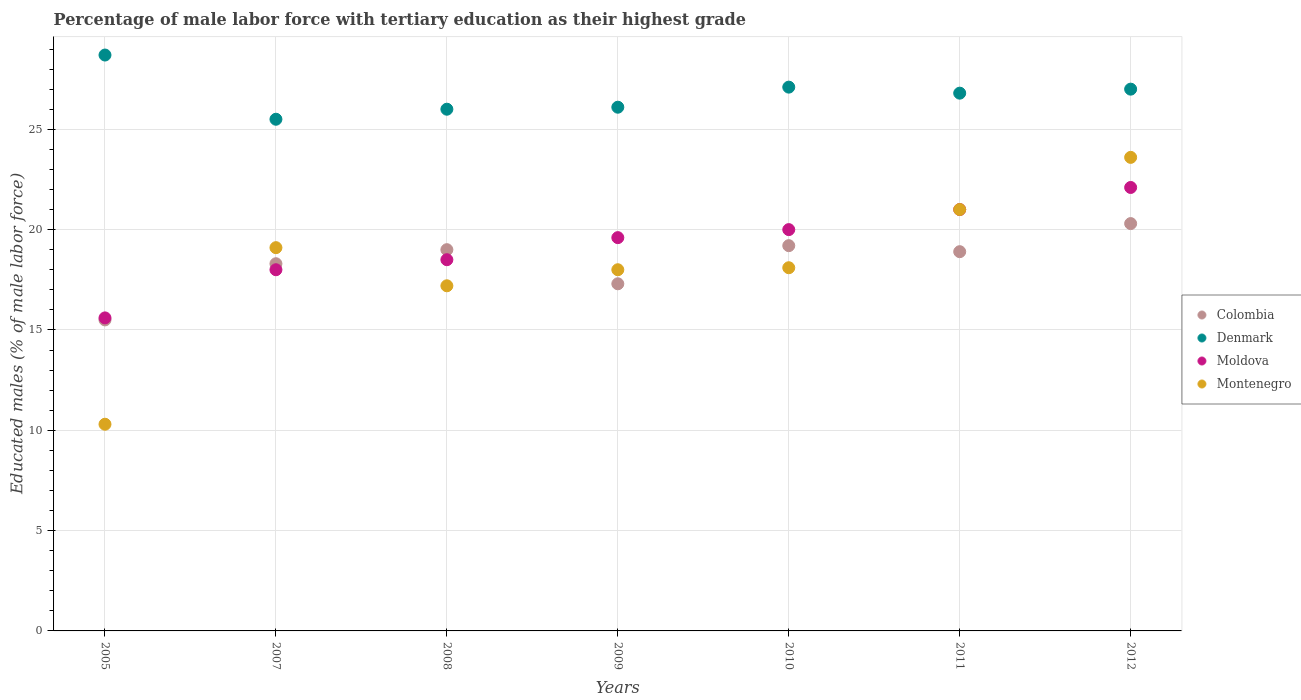What is the percentage of male labor force with tertiary education in Moldova in 2009?
Give a very brief answer. 19.6. Across all years, what is the maximum percentage of male labor force with tertiary education in Moldova?
Provide a succinct answer. 22.1. Across all years, what is the minimum percentage of male labor force with tertiary education in Colombia?
Provide a succinct answer. 15.5. In which year was the percentage of male labor force with tertiary education in Denmark maximum?
Ensure brevity in your answer.  2005. In which year was the percentage of male labor force with tertiary education in Denmark minimum?
Your answer should be very brief. 2007. What is the total percentage of male labor force with tertiary education in Colombia in the graph?
Give a very brief answer. 128.5. What is the difference between the percentage of male labor force with tertiary education in Denmark in 2009 and that in 2012?
Your answer should be very brief. -0.9. What is the difference between the percentage of male labor force with tertiary education in Moldova in 2011 and the percentage of male labor force with tertiary education in Montenegro in 2012?
Offer a very short reply. -2.6. What is the average percentage of male labor force with tertiary education in Colombia per year?
Make the answer very short. 18.36. In the year 2011, what is the difference between the percentage of male labor force with tertiary education in Denmark and percentage of male labor force with tertiary education in Colombia?
Provide a succinct answer. 7.9. What is the ratio of the percentage of male labor force with tertiary education in Moldova in 2010 to that in 2012?
Your answer should be compact. 0.9. Is the difference between the percentage of male labor force with tertiary education in Denmark in 2008 and 2012 greater than the difference between the percentage of male labor force with tertiary education in Colombia in 2008 and 2012?
Provide a short and direct response. Yes. What is the difference between the highest and the second highest percentage of male labor force with tertiary education in Colombia?
Your response must be concise. 1.1. What is the difference between the highest and the lowest percentage of male labor force with tertiary education in Montenegro?
Your response must be concise. 13.3. Is it the case that in every year, the sum of the percentage of male labor force with tertiary education in Denmark and percentage of male labor force with tertiary education in Moldova  is greater than the sum of percentage of male labor force with tertiary education in Montenegro and percentage of male labor force with tertiary education in Colombia?
Offer a terse response. Yes. What is the difference between two consecutive major ticks on the Y-axis?
Offer a terse response. 5. Are the values on the major ticks of Y-axis written in scientific E-notation?
Keep it short and to the point. No. Does the graph contain any zero values?
Your response must be concise. No. Does the graph contain grids?
Provide a short and direct response. Yes. How are the legend labels stacked?
Your answer should be compact. Vertical. What is the title of the graph?
Provide a succinct answer. Percentage of male labor force with tertiary education as their highest grade. Does "San Marino" appear as one of the legend labels in the graph?
Your response must be concise. No. What is the label or title of the X-axis?
Offer a very short reply. Years. What is the label or title of the Y-axis?
Provide a succinct answer. Educated males (% of male labor force). What is the Educated males (% of male labor force) of Denmark in 2005?
Give a very brief answer. 28.7. What is the Educated males (% of male labor force) in Moldova in 2005?
Make the answer very short. 15.6. What is the Educated males (% of male labor force) in Montenegro in 2005?
Your answer should be compact. 10.3. What is the Educated males (% of male labor force) in Colombia in 2007?
Offer a terse response. 18.3. What is the Educated males (% of male labor force) of Denmark in 2007?
Your response must be concise. 25.5. What is the Educated males (% of male labor force) in Moldova in 2007?
Your response must be concise. 18. What is the Educated males (% of male labor force) of Montenegro in 2007?
Keep it short and to the point. 19.1. What is the Educated males (% of male labor force) of Colombia in 2008?
Keep it short and to the point. 19. What is the Educated males (% of male labor force) of Denmark in 2008?
Make the answer very short. 26. What is the Educated males (% of male labor force) of Montenegro in 2008?
Provide a succinct answer. 17.2. What is the Educated males (% of male labor force) in Colombia in 2009?
Your answer should be very brief. 17.3. What is the Educated males (% of male labor force) in Denmark in 2009?
Provide a short and direct response. 26.1. What is the Educated males (% of male labor force) of Moldova in 2009?
Make the answer very short. 19.6. What is the Educated males (% of male labor force) of Montenegro in 2009?
Give a very brief answer. 18. What is the Educated males (% of male labor force) in Colombia in 2010?
Provide a short and direct response. 19.2. What is the Educated males (% of male labor force) in Denmark in 2010?
Your response must be concise. 27.1. What is the Educated males (% of male labor force) in Moldova in 2010?
Your answer should be very brief. 20. What is the Educated males (% of male labor force) in Montenegro in 2010?
Make the answer very short. 18.1. What is the Educated males (% of male labor force) of Colombia in 2011?
Provide a succinct answer. 18.9. What is the Educated males (% of male labor force) of Denmark in 2011?
Provide a short and direct response. 26.8. What is the Educated males (% of male labor force) of Moldova in 2011?
Make the answer very short. 21. What is the Educated males (% of male labor force) in Montenegro in 2011?
Ensure brevity in your answer.  21. What is the Educated males (% of male labor force) in Colombia in 2012?
Your answer should be compact. 20.3. What is the Educated males (% of male labor force) of Moldova in 2012?
Offer a terse response. 22.1. What is the Educated males (% of male labor force) in Montenegro in 2012?
Your answer should be compact. 23.6. Across all years, what is the maximum Educated males (% of male labor force) of Colombia?
Make the answer very short. 20.3. Across all years, what is the maximum Educated males (% of male labor force) of Denmark?
Provide a short and direct response. 28.7. Across all years, what is the maximum Educated males (% of male labor force) of Moldova?
Give a very brief answer. 22.1. Across all years, what is the maximum Educated males (% of male labor force) of Montenegro?
Keep it short and to the point. 23.6. Across all years, what is the minimum Educated males (% of male labor force) of Denmark?
Offer a very short reply. 25.5. Across all years, what is the minimum Educated males (% of male labor force) of Moldova?
Offer a terse response. 15.6. Across all years, what is the minimum Educated males (% of male labor force) in Montenegro?
Your response must be concise. 10.3. What is the total Educated males (% of male labor force) in Colombia in the graph?
Offer a very short reply. 128.5. What is the total Educated males (% of male labor force) of Denmark in the graph?
Offer a terse response. 187.2. What is the total Educated males (% of male labor force) in Moldova in the graph?
Offer a very short reply. 134.8. What is the total Educated males (% of male labor force) of Montenegro in the graph?
Make the answer very short. 127.3. What is the difference between the Educated males (% of male labor force) of Colombia in 2005 and that in 2007?
Provide a succinct answer. -2.8. What is the difference between the Educated males (% of male labor force) in Denmark in 2005 and that in 2007?
Your answer should be very brief. 3.2. What is the difference between the Educated males (% of male labor force) of Moldova in 2005 and that in 2007?
Provide a short and direct response. -2.4. What is the difference between the Educated males (% of male labor force) of Montenegro in 2005 and that in 2007?
Make the answer very short. -8.8. What is the difference between the Educated males (% of male labor force) of Denmark in 2005 and that in 2008?
Provide a succinct answer. 2.7. What is the difference between the Educated males (% of male labor force) in Montenegro in 2005 and that in 2008?
Give a very brief answer. -6.9. What is the difference between the Educated males (% of male labor force) in Colombia in 2005 and that in 2009?
Your answer should be very brief. -1.8. What is the difference between the Educated males (% of male labor force) in Denmark in 2005 and that in 2009?
Ensure brevity in your answer.  2.6. What is the difference between the Educated males (% of male labor force) in Moldova in 2005 and that in 2009?
Offer a terse response. -4. What is the difference between the Educated males (% of male labor force) of Colombia in 2005 and that in 2010?
Offer a very short reply. -3.7. What is the difference between the Educated males (% of male labor force) in Denmark in 2005 and that in 2010?
Provide a succinct answer. 1.6. What is the difference between the Educated males (% of male labor force) in Colombia in 2005 and that in 2011?
Provide a short and direct response. -3.4. What is the difference between the Educated males (% of male labor force) of Denmark in 2005 and that in 2011?
Provide a succinct answer. 1.9. What is the difference between the Educated males (% of male labor force) of Montenegro in 2005 and that in 2011?
Ensure brevity in your answer.  -10.7. What is the difference between the Educated males (% of male labor force) in Moldova in 2005 and that in 2012?
Make the answer very short. -6.5. What is the difference between the Educated males (% of male labor force) in Colombia in 2007 and that in 2008?
Keep it short and to the point. -0.7. What is the difference between the Educated males (% of male labor force) of Colombia in 2007 and that in 2009?
Your answer should be very brief. 1. What is the difference between the Educated males (% of male labor force) in Denmark in 2007 and that in 2009?
Your response must be concise. -0.6. What is the difference between the Educated males (% of male labor force) of Montenegro in 2007 and that in 2009?
Give a very brief answer. 1.1. What is the difference between the Educated males (% of male labor force) in Denmark in 2007 and that in 2010?
Provide a succinct answer. -1.6. What is the difference between the Educated males (% of male labor force) of Montenegro in 2007 and that in 2010?
Your answer should be very brief. 1. What is the difference between the Educated males (% of male labor force) of Denmark in 2007 and that in 2011?
Give a very brief answer. -1.3. What is the difference between the Educated males (% of male labor force) in Denmark in 2007 and that in 2012?
Make the answer very short. -1.5. What is the difference between the Educated males (% of male labor force) in Montenegro in 2007 and that in 2012?
Your answer should be compact. -4.5. What is the difference between the Educated males (% of male labor force) of Moldova in 2008 and that in 2009?
Provide a short and direct response. -1.1. What is the difference between the Educated males (% of male labor force) of Montenegro in 2008 and that in 2009?
Your answer should be compact. -0.8. What is the difference between the Educated males (% of male labor force) in Colombia in 2008 and that in 2010?
Make the answer very short. -0.2. What is the difference between the Educated males (% of male labor force) of Denmark in 2008 and that in 2010?
Your response must be concise. -1.1. What is the difference between the Educated males (% of male labor force) of Colombia in 2008 and that in 2011?
Your answer should be compact. 0.1. What is the difference between the Educated males (% of male labor force) of Denmark in 2008 and that in 2011?
Your response must be concise. -0.8. What is the difference between the Educated males (% of male labor force) in Montenegro in 2008 and that in 2011?
Ensure brevity in your answer.  -3.8. What is the difference between the Educated males (% of male labor force) in Montenegro in 2008 and that in 2012?
Provide a short and direct response. -6.4. What is the difference between the Educated males (% of male labor force) of Colombia in 2009 and that in 2010?
Your answer should be very brief. -1.9. What is the difference between the Educated males (% of male labor force) in Denmark in 2009 and that in 2010?
Your response must be concise. -1. What is the difference between the Educated males (% of male labor force) of Montenegro in 2009 and that in 2010?
Your response must be concise. -0.1. What is the difference between the Educated males (% of male labor force) of Colombia in 2009 and that in 2011?
Keep it short and to the point. -1.6. What is the difference between the Educated males (% of male labor force) in Denmark in 2009 and that in 2011?
Give a very brief answer. -0.7. What is the difference between the Educated males (% of male labor force) of Moldova in 2009 and that in 2011?
Offer a very short reply. -1.4. What is the difference between the Educated males (% of male labor force) in Montenegro in 2009 and that in 2011?
Give a very brief answer. -3. What is the difference between the Educated males (% of male labor force) of Colombia in 2009 and that in 2012?
Make the answer very short. -3. What is the difference between the Educated males (% of male labor force) in Colombia in 2010 and that in 2011?
Your answer should be compact. 0.3. What is the difference between the Educated males (% of male labor force) of Denmark in 2010 and that in 2011?
Your answer should be very brief. 0.3. What is the difference between the Educated males (% of male labor force) in Montenegro in 2010 and that in 2011?
Offer a terse response. -2.9. What is the difference between the Educated males (% of male labor force) of Colombia in 2010 and that in 2012?
Offer a terse response. -1.1. What is the difference between the Educated males (% of male labor force) of Moldova in 2010 and that in 2012?
Offer a terse response. -2.1. What is the difference between the Educated males (% of male labor force) of Moldova in 2011 and that in 2012?
Offer a very short reply. -1.1. What is the difference between the Educated males (% of male labor force) of Colombia in 2005 and the Educated males (% of male labor force) of Denmark in 2007?
Provide a short and direct response. -10. What is the difference between the Educated males (% of male labor force) of Colombia in 2005 and the Educated males (% of male labor force) of Moldova in 2007?
Provide a short and direct response. -2.5. What is the difference between the Educated males (% of male labor force) in Denmark in 2005 and the Educated males (% of male labor force) in Moldova in 2007?
Offer a terse response. 10.7. What is the difference between the Educated males (% of male labor force) of Denmark in 2005 and the Educated males (% of male labor force) of Moldova in 2008?
Offer a very short reply. 10.2. What is the difference between the Educated males (% of male labor force) in Denmark in 2005 and the Educated males (% of male labor force) in Montenegro in 2008?
Your answer should be compact. 11.5. What is the difference between the Educated males (% of male labor force) in Colombia in 2005 and the Educated males (% of male labor force) in Moldova in 2009?
Provide a succinct answer. -4.1. What is the difference between the Educated males (% of male labor force) of Colombia in 2005 and the Educated males (% of male labor force) of Montenegro in 2009?
Your answer should be compact. -2.5. What is the difference between the Educated males (% of male labor force) in Denmark in 2005 and the Educated males (% of male labor force) in Montenegro in 2009?
Give a very brief answer. 10.7. What is the difference between the Educated males (% of male labor force) of Colombia in 2005 and the Educated males (% of male labor force) of Montenegro in 2010?
Give a very brief answer. -2.6. What is the difference between the Educated males (% of male labor force) of Denmark in 2005 and the Educated males (% of male labor force) of Montenegro in 2010?
Give a very brief answer. 10.6. What is the difference between the Educated males (% of male labor force) of Moldova in 2005 and the Educated males (% of male labor force) of Montenegro in 2010?
Provide a short and direct response. -2.5. What is the difference between the Educated males (% of male labor force) in Colombia in 2005 and the Educated males (% of male labor force) in Denmark in 2011?
Your answer should be very brief. -11.3. What is the difference between the Educated males (% of male labor force) of Colombia in 2005 and the Educated males (% of male labor force) of Moldova in 2011?
Offer a terse response. -5.5. What is the difference between the Educated males (% of male labor force) in Colombia in 2005 and the Educated males (% of male labor force) in Montenegro in 2011?
Provide a succinct answer. -5.5. What is the difference between the Educated males (% of male labor force) of Moldova in 2005 and the Educated males (% of male labor force) of Montenegro in 2011?
Your answer should be compact. -5.4. What is the difference between the Educated males (% of male labor force) of Colombia in 2005 and the Educated males (% of male labor force) of Denmark in 2012?
Keep it short and to the point. -11.5. What is the difference between the Educated males (% of male labor force) in Colombia in 2005 and the Educated males (% of male labor force) in Moldova in 2012?
Give a very brief answer. -6.6. What is the difference between the Educated males (% of male labor force) in Denmark in 2005 and the Educated males (% of male labor force) in Moldova in 2012?
Provide a succinct answer. 6.6. What is the difference between the Educated males (% of male labor force) in Denmark in 2005 and the Educated males (% of male labor force) in Montenegro in 2012?
Ensure brevity in your answer.  5.1. What is the difference between the Educated males (% of male labor force) in Colombia in 2007 and the Educated males (% of male labor force) in Denmark in 2008?
Give a very brief answer. -7.7. What is the difference between the Educated males (% of male labor force) in Colombia in 2007 and the Educated males (% of male labor force) in Moldova in 2008?
Provide a short and direct response. -0.2. What is the difference between the Educated males (% of male labor force) in Colombia in 2007 and the Educated males (% of male labor force) in Montenegro in 2008?
Make the answer very short. 1.1. What is the difference between the Educated males (% of male labor force) in Moldova in 2007 and the Educated males (% of male labor force) in Montenegro in 2008?
Your response must be concise. 0.8. What is the difference between the Educated males (% of male labor force) of Colombia in 2007 and the Educated males (% of male labor force) of Denmark in 2009?
Provide a succinct answer. -7.8. What is the difference between the Educated males (% of male labor force) in Colombia in 2007 and the Educated males (% of male labor force) in Moldova in 2009?
Provide a short and direct response. -1.3. What is the difference between the Educated males (% of male labor force) in Moldova in 2007 and the Educated males (% of male labor force) in Montenegro in 2009?
Keep it short and to the point. 0. What is the difference between the Educated males (% of male labor force) of Colombia in 2007 and the Educated males (% of male labor force) of Denmark in 2010?
Give a very brief answer. -8.8. What is the difference between the Educated males (% of male labor force) in Denmark in 2007 and the Educated males (% of male labor force) in Moldova in 2010?
Your response must be concise. 5.5. What is the difference between the Educated males (% of male labor force) in Denmark in 2007 and the Educated males (% of male labor force) in Montenegro in 2010?
Offer a very short reply. 7.4. What is the difference between the Educated males (% of male labor force) in Moldova in 2007 and the Educated males (% of male labor force) in Montenegro in 2010?
Keep it short and to the point. -0.1. What is the difference between the Educated males (% of male labor force) in Colombia in 2007 and the Educated males (% of male labor force) in Moldova in 2011?
Provide a succinct answer. -2.7. What is the difference between the Educated males (% of male labor force) in Colombia in 2007 and the Educated males (% of male labor force) in Montenegro in 2011?
Your response must be concise. -2.7. What is the difference between the Educated males (% of male labor force) in Denmark in 2007 and the Educated males (% of male labor force) in Moldova in 2011?
Make the answer very short. 4.5. What is the difference between the Educated males (% of male labor force) in Colombia in 2007 and the Educated males (% of male labor force) in Montenegro in 2012?
Offer a very short reply. -5.3. What is the difference between the Educated males (% of male labor force) in Colombia in 2008 and the Educated males (% of male labor force) in Denmark in 2009?
Your response must be concise. -7.1. What is the difference between the Educated males (% of male labor force) of Colombia in 2008 and the Educated males (% of male labor force) of Montenegro in 2009?
Offer a very short reply. 1. What is the difference between the Educated males (% of male labor force) in Denmark in 2008 and the Educated males (% of male labor force) in Moldova in 2009?
Your response must be concise. 6.4. What is the difference between the Educated males (% of male labor force) of Moldova in 2008 and the Educated males (% of male labor force) of Montenegro in 2009?
Your answer should be compact. 0.5. What is the difference between the Educated males (% of male labor force) of Colombia in 2008 and the Educated males (% of male labor force) of Montenegro in 2010?
Provide a short and direct response. 0.9. What is the difference between the Educated males (% of male labor force) of Denmark in 2008 and the Educated males (% of male labor force) of Moldova in 2010?
Ensure brevity in your answer.  6. What is the difference between the Educated males (% of male labor force) in Moldova in 2008 and the Educated males (% of male labor force) in Montenegro in 2010?
Give a very brief answer. 0.4. What is the difference between the Educated males (% of male labor force) in Colombia in 2008 and the Educated males (% of male labor force) in Denmark in 2011?
Provide a succinct answer. -7.8. What is the difference between the Educated males (% of male labor force) in Colombia in 2008 and the Educated males (% of male labor force) in Moldova in 2011?
Offer a terse response. -2. What is the difference between the Educated males (% of male labor force) of Colombia in 2008 and the Educated males (% of male labor force) of Montenegro in 2011?
Ensure brevity in your answer.  -2. What is the difference between the Educated males (% of male labor force) of Denmark in 2008 and the Educated males (% of male labor force) of Moldova in 2011?
Give a very brief answer. 5. What is the difference between the Educated males (% of male labor force) of Denmark in 2008 and the Educated males (% of male labor force) of Montenegro in 2011?
Ensure brevity in your answer.  5. What is the difference between the Educated males (% of male labor force) in Moldova in 2008 and the Educated males (% of male labor force) in Montenegro in 2011?
Ensure brevity in your answer.  -2.5. What is the difference between the Educated males (% of male labor force) in Colombia in 2008 and the Educated males (% of male labor force) in Denmark in 2012?
Keep it short and to the point. -8. What is the difference between the Educated males (% of male labor force) in Colombia in 2008 and the Educated males (% of male labor force) in Moldova in 2012?
Offer a very short reply. -3.1. What is the difference between the Educated males (% of male labor force) in Denmark in 2008 and the Educated males (% of male labor force) in Montenegro in 2012?
Offer a terse response. 2.4. What is the difference between the Educated males (% of male labor force) in Moldova in 2008 and the Educated males (% of male labor force) in Montenegro in 2012?
Keep it short and to the point. -5.1. What is the difference between the Educated males (% of male labor force) of Colombia in 2009 and the Educated males (% of male labor force) of Montenegro in 2010?
Provide a short and direct response. -0.8. What is the difference between the Educated males (% of male labor force) of Denmark in 2009 and the Educated males (% of male labor force) of Moldova in 2010?
Offer a terse response. 6.1. What is the difference between the Educated males (% of male labor force) of Denmark in 2009 and the Educated males (% of male labor force) of Montenegro in 2010?
Give a very brief answer. 8. What is the difference between the Educated males (% of male labor force) of Colombia in 2009 and the Educated males (% of male labor force) of Denmark in 2011?
Ensure brevity in your answer.  -9.5. What is the difference between the Educated males (% of male labor force) of Colombia in 2009 and the Educated males (% of male labor force) of Montenegro in 2011?
Offer a terse response. -3.7. What is the difference between the Educated males (% of male labor force) of Colombia in 2009 and the Educated males (% of male labor force) of Denmark in 2012?
Keep it short and to the point. -9.7. What is the difference between the Educated males (% of male labor force) of Colombia in 2009 and the Educated males (% of male labor force) of Montenegro in 2012?
Make the answer very short. -6.3. What is the difference between the Educated males (% of male labor force) in Denmark in 2009 and the Educated males (% of male labor force) in Montenegro in 2012?
Give a very brief answer. 2.5. What is the difference between the Educated males (% of male labor force) of Colombia in 2010 and the Educated males (% of male labor force) of Denmark in 2011?
Provide a short and direct response. -7.6. What is the difference between the Educated males (% of male labor force) in Colombia in 2010 and the Educated males (% of male labor force) in Montenegro in 2011?
Keep it short and to the point. -1.8. What is the difference between the Educated males (% of male labor force) of Denmark in 2010 and the Educated males (% of male labor force) of Moldova in 2011?
Provide a succinct answer. 6.1. What is the difference between the Educated males (% of male labor force) of Denmark in 2010 and the Educated males (% of male labor force) of Montenegro in 2011?
Provide a short and direct response. 6.1. What is the difference between the Educated males (% of male labor force) in Colombia in 2010 and the Educated males (% of male labor force) in Moldova in 2012?
Your answer should be compact. -2.9. What is the difference between the Educated males (% of male labor force) of Colombia in 2010 and the Educated males (% of male labor force) of Montenegro in 2012?
Your answer should be very brief. -4.4. What is the difference between the Educated males (% of male labor force) of Denmark in 2010 and the Educated males (% of male labor force) of Moldova in 2012?
Your answer should be very brief. 5. What is the difference between the Educated males (% of male labor force) of Moldova in 2010 and the Educated males (% of male labor force) of Montenegro in 2012?
Provide a succinct answer. -3.6. What is the difference between the Educated males (% of male labor force) of Colombia in 2011 and the Educated males (% of male labor force) of Denmark in 2012?
Keep it short and to the point. -8.1. What is the difference between the Educated males (% of male labor force) in Colombia in 2011 and the Educated males (% of male labor force) in Moldova in 2012?
Ensure brevity in your answer.  -3.2. What is the difference between the Educated males (% of male labor force) in Denmark in 2011 and the Educated males (% of male labor force) in Moldova in 2012?
Provide a succinct answer. 4.7. What is the average Educated males (% of male labor force) in Colombia per year?
Your answer should be very brief. 18.36. What is the average Educated males (% of male labor force) in Denmark per year?
Ensure brevity in your answer.  26.74. What is the average Educated males (% of male labor force) in Moldova per year?
Ensure brevity in your answer.  19.26. What is the average Educated males (% of male labor force) in Montenegro per year?
Keep it short and to the point. 18.19. In the year 2005, what is the difference between the Educated males (% of male labor force) in Colombia and Educated males (% of male labor force) in Moldova?
Your answer should be compact. -0.1. In the year 2005, what is the difference between the Educated males (% of male labor force) of Colombia and Educated males (% of male labor force) of Montenegro?
Ensure brevity in your answer.  5.2. In the year 2007, what is the difference between the Educated males (% of male labor force) in Colombia and Educated males (% of male labor force) in Denmark?
Your answer should be very brief. -7.2. In the year 2007, what is the difference between the Educated males (% of male labor force) of Colombia and Educated males (% of male labor force) of Montenegro?
Ensure brevity in your answer.  -0.8. In the year 2007, what is the difference between the Educated males (% of male labor force) in Denmark and Educated males (% of male labor force) in Moldova?
Your answer should be compact. 7.5. In the year 2007, what is the difference between the Educated males (% of male labor force) of Moldova and Educated males (% of male labor force) of Montenegro?
Provide a succinct answer. -1.1. In the year 2008, what is the difference between the Educated males (% of male labor force) in Colombia and Educated males (% of male labor force) in Moldova?
Give a very brief answer. 0.5. In the year 2008, what is the difference between the Educated males (% of male labor force) of Colombia and Educated males (% of male labor force) of Montenegro?
Ensure brevity in your answer.  1.8. In the year 2008, what is the difference between the Educated males (% of male labor force) of Denmark and Educated males (% of male labor force) of Moldova?
Your response must be concise. 7.5. In the year 2009, what is the difference between the Educated males (% of male labor force) of Colombia and Educated males (% of male labor force) of Moldova?
Your answer should be very brief. -2.3. In the year 2009, what is the difference between the Educated males (% of male labor force) of Moldova and Educated males (% of male labor force) of Montenegro?
Ensure brevity in your answer.  1.6. In the year 2010, what is the difference between the Educated males (% of male labor force) of Colombia and Educated males (% of male labor force) of Moldova?
Ensure brevity in your answer.  -0.8. In the year 2010, what is the difference between the Educated males (% of male labor force) in Colombia and Educated males (% of male labor force) in Montenegro?
Your response must be concise. 1.1. In the year 2011, what is the difference between the Educated males (% of male labor force) of Colombia and Educated males (% of male labor force) of Denmark?
Your answer should be compact. -7.9. In the year 2011, what is the difference between the Educated males (% of male labor force) in Denmark and Educated males (% of male labor force) in Montenegro?
Offer a terse response. 5.8. In the year 2012, what is the difference between the Educated males (% of male labor force) of Colombia and Educated males (% of male labor force) of Denmark?
Your response must be concise. -6.7. In the year 2012, what is the difference between the Educated males (% of male labor force) of Colombia and Educated males (% of male labor force) of Montenegro?
Offer a very short reply. -3.3. In the year 2012, what is the difference between the Educated males (% of male labor force) of Denmark and Educated males (% of male labor force) of Moldova?
Provide a short and direct response. 4.9. In the year 2012, what is the difference between the Educated males (% of male labor force) in Denmark and Educated males (% of male labor force) in Montenegro?
Provide a succinct answer. 3.4. What is the ratio of the Educated males (% of male labor force) in Colombia in 2005 to that in 2007?
Offer a very short reply. 0.85. What is the ratio of the Educated males (% of male labor force) in Denmark in 2005 to that in 2007?
Offer a very short reply. 1.13. What is the ratio of the Educated males (% of male labor force) of Moldova in 2005 to that in 2007?
Provide a succinct answer. 0.87. What is the ratio of the Educated males (% of male labor force) of Montenegro in 2005 to that in 2007?
Keep it short and to the point. 0.54. What is the ratio of the Educated males (% of male labor force) of Colombia in 2005 to that in 2008?
Give a very brief answer. 0.82. What is the ratio of the Educated males (% of male labor force) in Denmark in 2005 to that in 2008?
Offer a terse response. 1.1. What is the ratio of the Educated males (% of male labor force) in Moldova in 2005 to that in 2008?
Offer a terse response. 0.84. What is the ratio of the Educated males (% of male labor force) in Montenegro in 2005 to that in 2008?
Keep it short and to the point. 0.6. What is the ratio of the Educated males (% of male labor force) of Colombia in 2005 to that in 2009?
Your answer should be very brief. 0.9. What is the ratio of the Educated males (% of male labor force) of Denmark in 2005 to that in 2009?
Give a very brief answer. 1.1. What is the ratio of the Educated males (% of male labor force) of Moldova in 2005 to that in 2009?
Your answer should be very brief. 0.8. What is the ratio of the Educated males (% of male labor force) of Montenegro in 2005 to that in 2009?
Give a very brief answer. 0.57. What is the ratio of the Educated males (% of male labor force) of Colombia in 2005 to that in 2010?
Your response must be concise. 0.81. What is the ratio of the Educated males (% of male labor force) in Denmark in 2005 to that in 2010?
Your response must be concise. 1.06. What is the ratio of the Educated males (% of male labor force) in Moldova in 2005 to that in 2010?
Make the answer very short. 0.78. What is the ratio of the Educated males (% of male labor force) of Montenegro in 2005 to that in 2010?
Your answer should be compact. 0.57. What is the ratio of the Educated males (% of male labor force) of Colombia in 2005 to that in 2011?
Offer a terse response. 0.82. What is the ratio of the Educated males (% of male labor force) of Denmark in 2005 to that in 2011?
Ensure brevity in your answer.  1.07. What is the ratio of the Educated males (% of male labor force) in Moldova in 2005 to that in 2011?
Your answer should be compact. 0.74. What is the ratio of the Educated males (% of male labor force) in Montenegro in 2005 to that in 2011?
Your response must be concise. 0.49. What is the ratio of the Educated males (% of male labor force) in Colombia in 2005 to that in 2012?
Keep it short and to the point. 0.76. What is the ratio of the Educated males (% of male labor force) of Denmark in 2005 to that in 2012?
Give a very brief answer. 1.06. What is the ratio of the Educated males (% of male labor force) in Moldova in 2005 to that in 2012?
Your answer should be very brief. 0.71. What is the ratio of the Educated males (% of male labor force) of Montenegro in 2005 to that in 2012?
Your answer should be very brief. 0.44. What is the ratio of the Educated males (% of male labor force) in Colombia in 2007 to that in 2008?
Your answer should be very brief. 0.96. What is the ratio of the Educated males (% of male labor force) of Denmark in 2007 to that in 2008?
Your response must be concise. 0.98. What is the ratio of the Educated males (% of male labor force) in Moldova in 2007 to that in 2008?
Offer a very short reply. 0.97. What is the ratio of the Educated males (% of male labor force) in Montenegro in 2007 to that in 2008?
Your response must be concise. 1.11. What is the ratio of the Educated males (% of male labor force) of Colombia in 2007 to that in 2009?
Ensure brevity in your answer.  1.06. What is the ratio of the Educated males (% of male labor force) of Moldova in 2007 to that in 2009?
Ensure brevity in your answer.  0.92. What is the ratio of the Educated males (% of male labor force) in Montenegro in 2007 to that in 2009?
Your answer should be very brief. 1.06. What is the ratio of the Educated males (% of male labor force) in Colombia in 2007 to that in 2010?
Ensure brevity in your answer.  0.95. What is the ratio of the Educated males (% of male labor force) of Denmark in 2007 to that in 2010?
Your answer should be compact. 0.94. What is the ratio of the Educated males (% of male labor force) in Moldova in 2007 to that in 2010?
Your answer should be compact. 0.9. What is the ratio of the Educated males (% of male labor force) in Montenegro in 2007 to that in 2010?
Provide a succinct answer. 1.06. What is the ratio of the Educated males (% of male labor force) in Colombia in 2007 to that in 2011?
Ensure brevity in your answer.  0.97. What is the ratio of the Educated males (% of male labor force) in Denmark in 2007 to that in 2011?
Provide a succinct answer. 0.95. What is the ratio of the Educated males (% of male labor force) in Moldova in 2007 to that in 2011?
Ensure brevity in your answer.  0.86. What is the ratio of the Educated males (% of male labor force) of Montenegro in 2007 to that in 2011?
Your response must be concise. 0.91. What is the ratio of the Educated males (% of male labor force) of Colombia in 2007 to that in 2012?
Ensure brevity in your answer.  0.9. What is the ratio of the Educated males (% of male labor force) of Moldova in 2007 to that in 2012?
Give a very brief answer. 0.81. What is the ratio of the Educated males (% of male labor force) of Montenegro in 2007 to that in 2012?
Provide a short and direct response. 0.81. What is the ratio of the Educated males (% of male labor force) of Colombia in 2008 to that in 2009?
Provide a succinct answer. 1.1. What is the ratio of the Educated males (% of male labor force) of Moldova in 2008 to that in 2009?
Provide a short and direct response. 0.94. What is the ratio of the Educated males (% of male labor force) of Montenegro in 2008 to that in 2009?
Offer a very short reply. 0.96. What is the ratio of the Educated males (% of male labor force) of Denmark in 2008 to that in 2010?
Your response must be concise. 0.96. What is the ratio of the Educated males (% of male labor force) of Moldova in 2008 to that in 2010?
Provide a short and direct response. 0.93. What is the ratio of the Educated males (% of male labor force) of Montenegro in 2008 to that in 2010?
Keep it short and to the point. 0.95. What is the ratio of the Educated males (% of male labor force) in Denmark in 2008 to that in 2011?
Keep it short and to the point. 0.97. What is the ratio of the Educated males (% of male labor force) of Moldova in 2008 to that in 2011?
Offer a very short reply. 0.88. What is the ratio of the Educated males (% of male labor force) in Montenegro in 2008 to that in 2011?
Give a very brief answer. 0.82. What is the ratio of the Educated males (% of male labor force) of Colombia in 2008 to that in 2012?
Offer a terse response. 0.94. What is the ratio of the Educated males (% of male labor force) in Moldova in 2008 to that in 2012?
Provide a succinct answer. 0.84. What is the ratio of the Educated males (% of male labor force) in Montenegro in 2008 to that in 2012?
Provide a succinct answer. 0.73. What is the ratio of the Educated males (% of male labor force) in Colombia in 2009 to that in 2010?
Your answer should be compact. 0.9. What is the ratio of the Educated males (% of male labor force) in Denmark in 2009 to that in 2010?
Make the answer very short. 0.96. What is the ratio of the Educated males (% of male labor force) in Colombia in 2009 to that in 2011?
Offer a very short reply. 0.92. What is the ratio of the Educated males (% of male labor force) in Denmark in 2009 to that in 2011?
Your answer should be compact. 0.97. What is the ratio of the Educated males (% of male labor force) in Colombia in 2009 to that in 2012?
Provide a succinct answer. 0.85. What is the ratio of the Educated males (% of male labor force) in Denmark in 2009 to that in 2012?
Make the answer very short. 0.97. What is the ratio of the Educated males (% of male labor force) in Moldova in 2009 to that in 2012?
Your answer should be compact. 0.89. What is the ratio of the Educated males (% of male labor force) in Montenegro in 2009 to that in 2012?
Offer a terse response. 0.76. What is the ratio of the Educated males (% of male labor force) in Colombia in 2010 to that in 2011?
Provide a succinct answer. 1.02. What is the ratio of the Educated males (% of male labor force) in Denmark in 2010 to that in 2011?
Provide a succinct answer. 1.01. What is the ratio of the Educated males (% of male labor force) of Moldova in 2010 to that in 2011?
Provide a succinct answer. 0.95. What is the ratio of the Educated males (% of male labor force) in Montenegro in 2010 to that in 2011?
Provide a short and direct response. 0.86. What is the ratio of the Educated males (% of male labor force) in Colombia in 2010 to that in 2012?
Offer a terse response. 0.95. What is the ratio of the Educated males (% of male labor force) of Denmark in 2010 to that in 2012?
Give a very brief answer. 1. What is the ratio of the Educated males (% of male labor force) of Moldova in 2010 to that in 2012?
Your answer should be very brief. 0.91. What is the ratio of the Educated males (% of male labor force) of Montenegro in 2010 to that in 2012?
Make the answer very short. 0.77. What is the ratio of the Educated males (% of male labor force) in Moldova in 2011 to that in 2012?
Your answer should be compact. 0.95. What is the ratio of the Educated males (% of male labor force) of Montenegro in 2011 to that in 2012?
Provide a short and direct response. 0.89. What is the difference between the highest and the second highest Educated males (% of male labor force) in Colombia?
Offer a very short reply. 1.1. What is the difference between the highest and the second highest Educated males (% of male labor force) in Montenegro?
Offer a terse response. 2.6. What is the difference between the highest and the lowest Educated males (% of male labor force) in Moldova?
Your response must be concise. 6.5. What is the difference between the highest and the lowest Educated males (% of male labor force) of Montenegro?
Provide a short and direct response. 13.3. 